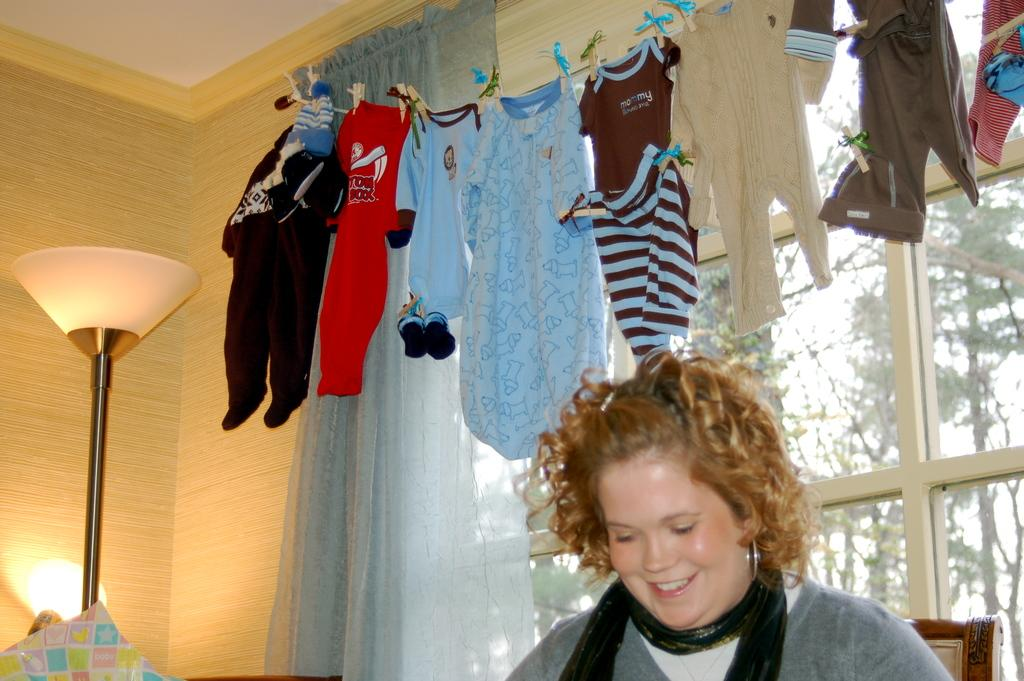What is being hung up in the image? Clothes are hanging in the image. Can you describe the person in the image? There is a woman in the image. What type of lighting is present in the image? There is a lamp in the image. What type of vegetation can be seen in the image? There are trees in the image. What type of window treatment is present in the image? There is a curtain in the image. Can you tell me how many bees are buzzing around the lamp in the image? There are no bees present in the image; it only features clothes hanging, a woman, a lamp, trees, and a curtain. What type of chalk is being used to draw on the trees in the image? There is no chalk or drawing on the trees in the image; it only features clothes hanging, a woman, a lamp, trees, and a curtain. 